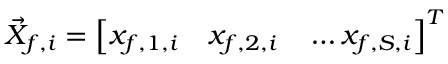<formula> <loc_0><loc_0><loc_500><loc_500>\vec { X } _ { f , i } = \left [ x _ { f , 1 , i } \quad x _ { f , 2 , i } \quad \dots x _ { f , S , i } \right ] ^ { T }</formula> 